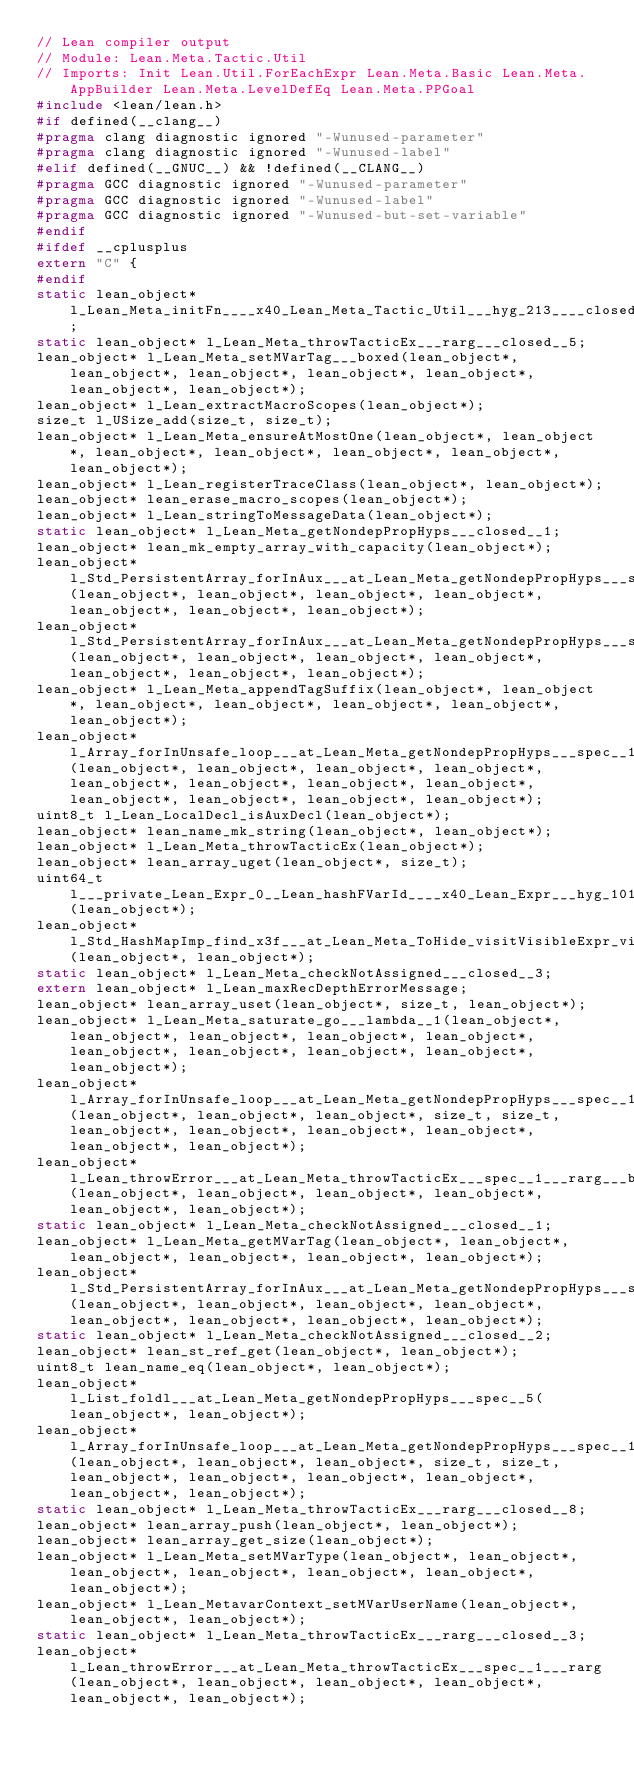<code> <loc_0><loc_0><loc_500><loc_500><_C_>// Lean compiler output
// Module: Lean.Meta.Tactic.Util
// Imports: Init Lean.Util.ForEachExpr Lean.Meta.Basic Lean.Meta.AppBuilder Lean.Meta.LevelDefEq Lean.Meta.PPGoal
#include <lean/lean.h>
#if defined(__clang__)
#pragma clang diagnostic ignored "-Wunused-parameter"
#pragma clang diagnostic ignored "-Wunused-label"
#elif defined(__GNUC__) && !defined(__CLANG__)
#pragma GCC diagnostic ignored "-Wunused-parameter"
#pragma GCC diagnostic ignored "-Wunused-label"
#pragma GCC diagnostic ignored "-Wunused-but-set-variable"
#endif
#ifdef __cplusplus
extern "C" {
#endif
static lean_object* l_Lean_Meta_initFn____x40_Lean_Meta_Tactic_Util___hyg_213____closed__4;
static lean_object* l_Lean_Meta_throwTacticEx___rarg___closed__5;
lean_object* l_Lean_Meta_setMVarTag___boxed(lean_object*, lean_object*, lean_object*, lean_object*, lean_object*, lean_object*, lean_object*);
lean_object* l_Lean_extractMacroScopes(lean_object*);
size_t l_USize_add(size_t, size_t);
lean_object* l_Lean_Meta_ensureAtMostOne(lean_object*, lean_object*, lean_object*, lean_object*, lean_object*, lean_object*, lean_object*);
lean_object* l_Lean_registerTraceClass(lean_object*, lean_object*);
lean_object* lean_erase_macro_scopes(lean_object*);
lean_object* l_Lean_stringToMessageData(lean_object*);
static lean_object* l_Lean_Meta_getNondepPropHyps___closed__1;
lean_object* lean_mk_empty_array_with_capacity(lean_object*);
lean_object* l_Std_PersistentArray_forInAux___at_Lean_Meta_getNondepPropHyps___spec__8___lambda__1(lean_object*, lean_object*, lean_object*, lean_object*, lean_object*, lean_object*, lean_object*);
lean_object* l_Std_PersistentArray_forInAux___at_Lean_Meta_getNondepPropHyps___spec__8___lambda__1___boxed(lean_object*, lean_object*, lean_object*, lean_object*, lean_object*, lean_object*, lean_object*);
lean_object* l_Lean_Meta_appendTagSuffix(lean_object*, lean_object*, lean_object*, lean_object*, lean_object*, lean_object*, lean_object*);
lean_object* l_Array_forInUnsafe_loop___at_Lean_Meta_getNondepPropHyps___spec__15___boxed(lean_object*, lean_object*, lean_object*, lean_object*, lean_object*, lean_object*, lean_object*, lean_object*, lean_object*, lean_object*, lean_object*, lean_object*);
uint8_t l_Lean_LocalDecl_isAuxDecl(lean_object*);
lean_object* lean_name_mk_string(lean_object*, lean_object*);
lean_object* l_Lean_Meta_throwTacticEx(lean_object*);
lean_object* lean_array_uget(lean_object*, size_t);
uint64_t l___private_Lean_Expr_0__Lean_hashFVarId____x40_Lean_Expr___hyg_1017_(lean_object*);
lean_object* l_Std_HashMapImp_find_x3f___at_Lean_Meta_ToHide_visitVisibleExpr_visit___spec__1(lean_object*, lean_object*);
static lean_object* l_Lean_Meta_checkNotAssigned___closed__3;
extern lean_object* l_Lean_maxRecDepthErrorMessage;
lean_object* lean_array_uset(lean_object*, size_t, lean_object*);
lean_object* l_Lean_Meta_saturate_go___lambda__1(lean_object*, lean_object*, lean_object*, lean_object*, lean_object*, lean_object*, lean_object*, lean_object*, lean_object*, lean_object*);
lean_object* l_Array_forInUnsafe_loop___at_Lean_Meta_getNondepPropHyps___spec__16(lean_object*, lean_object*, lean_object*, size_t, size_t, lean_object*, lean_object*, lean_object*, lean_object*, lean_object*, lean_object*);
lean_object* l_Lean_throwError___at_Lean_Meta_throwTacticEx___spec__1___rarg___boxed(lean_object*, lean_object*, lean_object*, lean_object*, lean_object*, lean_object*);
static lean_object* l_Lean_Meta_checkNotAssigned___closed__1;
lean_object* l_Lean_Meta_getMVarTag(lean_object*, lean_object*, lean_object*, lean_object*, lean_object*, lean_object*);
lean_object* l_Std_PersistentArray_forInAux___at_Lean_Meta_getNondepPropHyps___spec__8(lean_object*, lean_object*, lean_object*, lean_object*, lean_object*, lean_object*, lean_object*, lean_object*);
static lean_object* l_Lean_Meta_checkNotAssigned___closed__2;
lean_object* lean_st_ref_get(lean_object*, lean_object*);
uint8_t lean_name_eq(lean_object*, lean_object*);
lean_object* l_List_foldl___at_Lean_Meta_getNondepPropHyps___spec__5(lean_object*, lean_object*);
lean_object* l_Array_forInUnsafe_loop___at_Lean_Meta_getNondepPropHyps___spec__17(lean_object*, lean_object*, lean_object*, size_t, size_t, lean_object*, lean_object*, lean_object*, lean_object*, lean_object*, lean_object*);
static lean_object* l_Lean_Meta_throwTacticEx___rarg___closed__8;
lean_object* lean_array_push(lean_object*, lean_object*);
lean_object* lean_array_get_size(lean_object*);
lean_object* l_Lean_Meta_setMVarType(lean_object*, lean_object*, lean_object*, lean_object*, lean_object*, lean_object*, lean_object*);
lean_object* l_Lean_MetavarContext_setMVarUserName(lean_object*, lean_object*, lean_object*);
static lean_object* l_Lean_Meta_throwTacticEx___rarg___closed__3;
lean_object* l_Lean_throwError___at_Lean_Meta_throwTacticEx___spec__1___rarg(lean_object*, lean_object*, lean_object*, lean_object*, lean_object*, lean_object*);</code> 